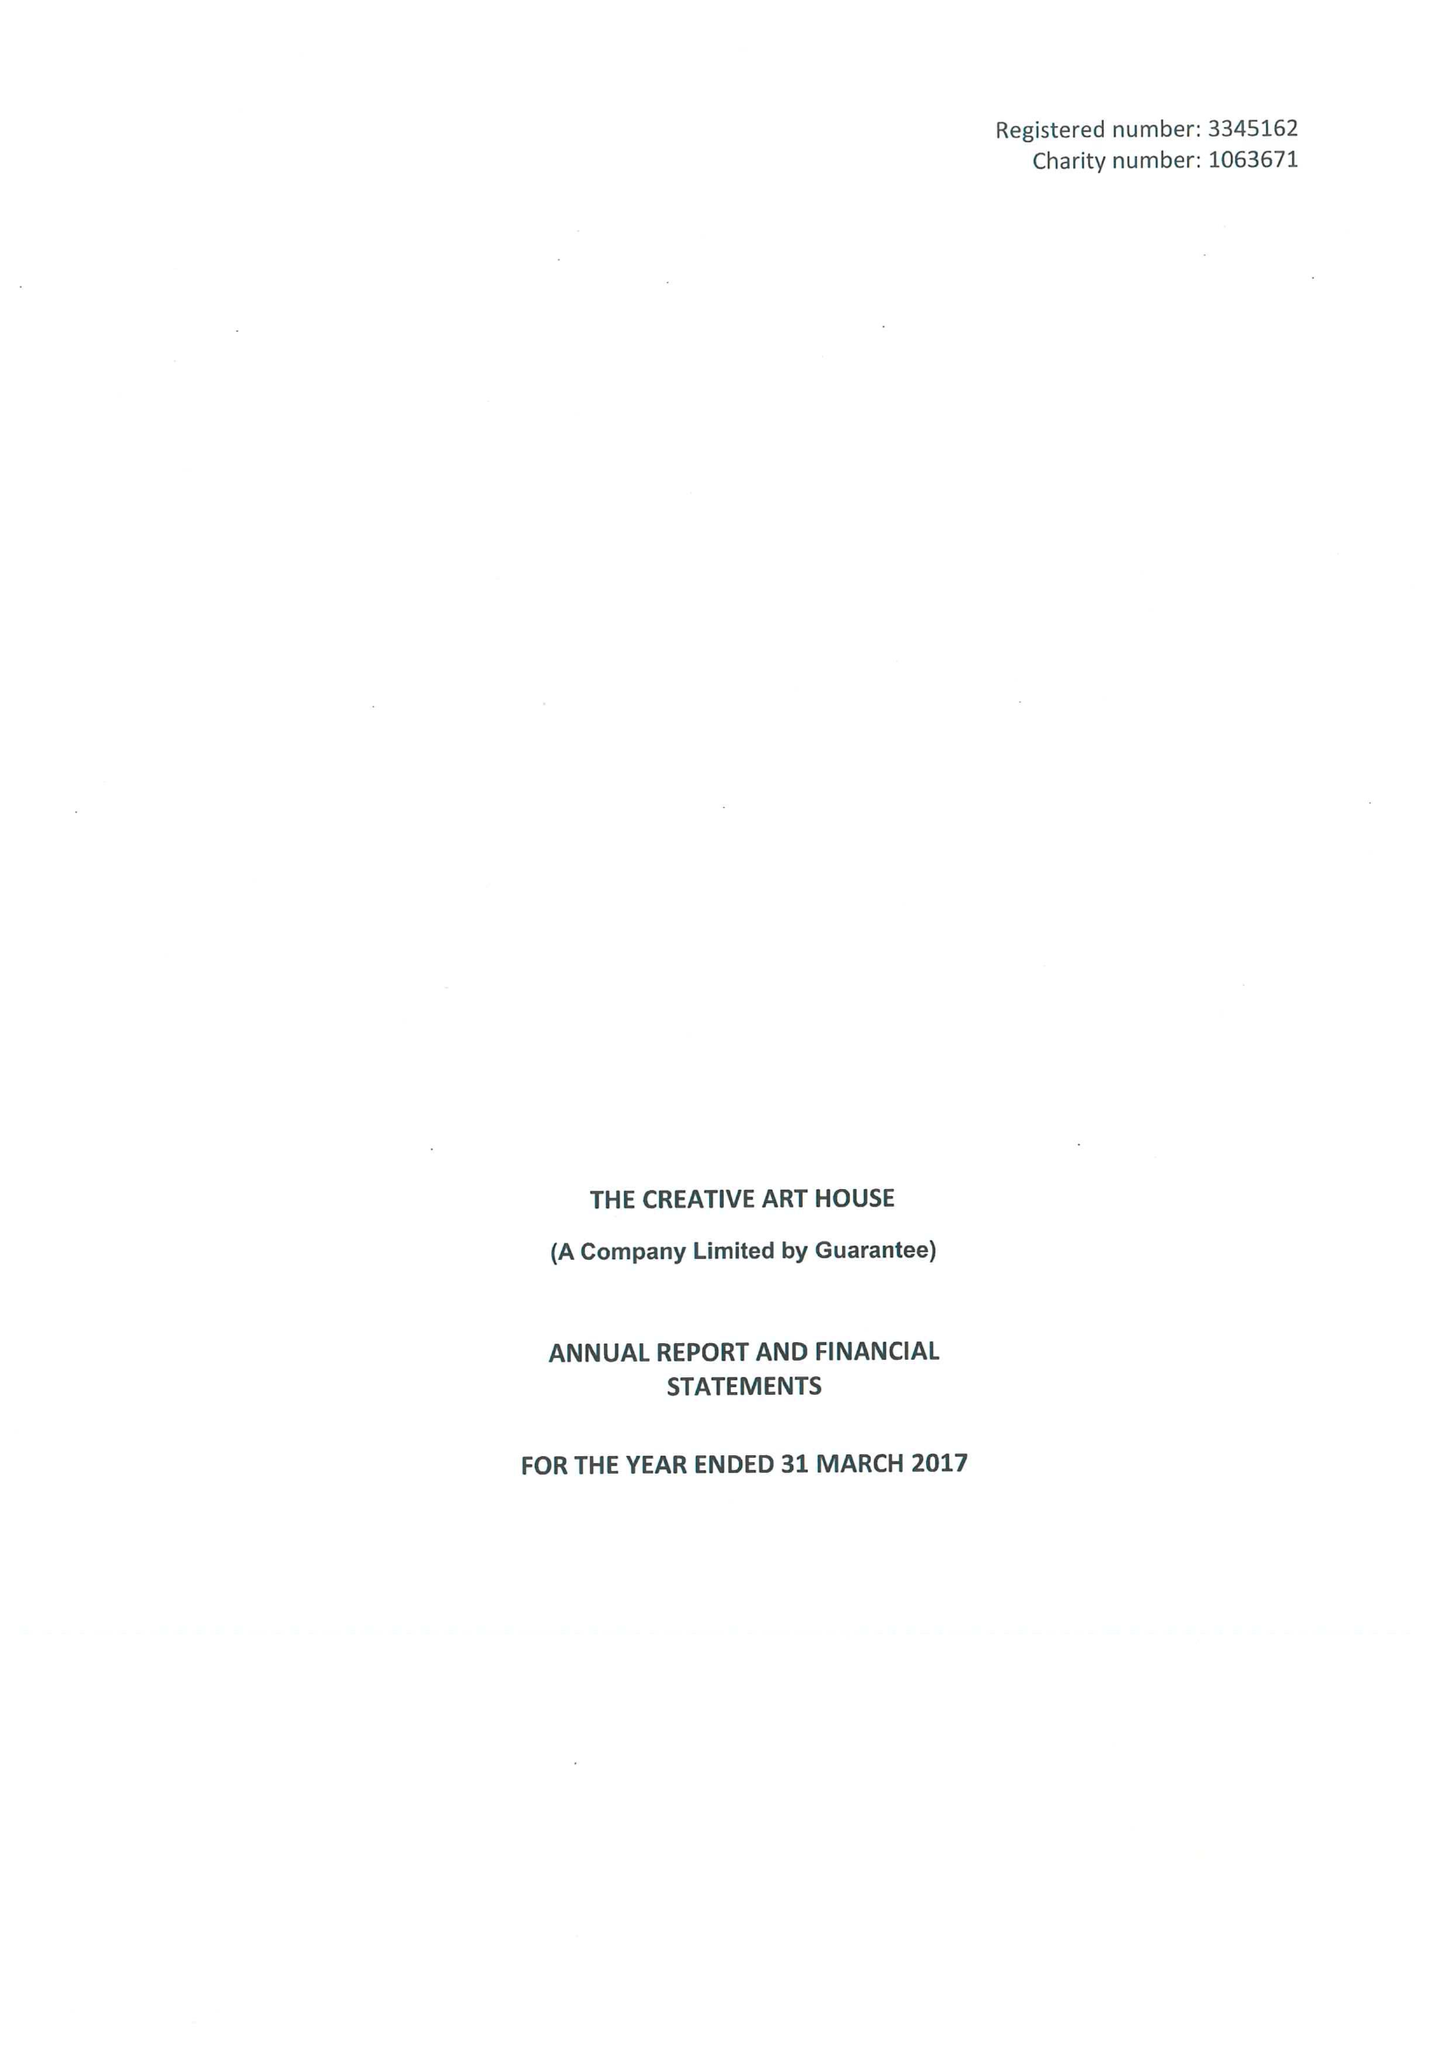What is the value for the address__postcode?
Answer the question using a single word or phrase. WF1 2TE 